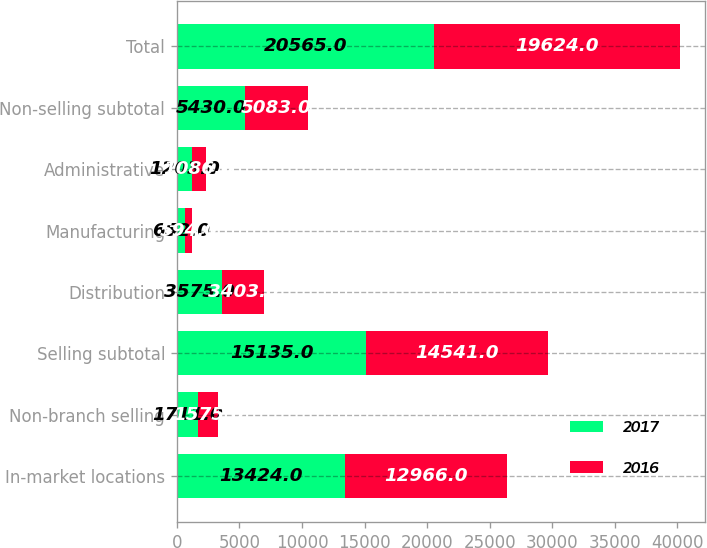<chart> <loc_0><loc_0><loc_500><loc_500><stacked_bar_chart><ecel><fcel>In-market locations<fcel>Non-branch selling<fcel>Selling subtotal<fcel>Distribution<fcel>Manufacturing<fcel>Administrative<fcel>Non-selling subtotal<fcel>Total<nl><fcel>2017<fcel>13424<fcel>1711<fcel>15135<fcel>3575<fcel>652<fcel>1203<fcel>5430<fcel>20565<nl><fcel>2016<fcel>12966<fcel>1575<fcel>14541<fcel>3403<fcel>594<fcel>1086<fcel>5083<fcel>19624<nl></chart> 